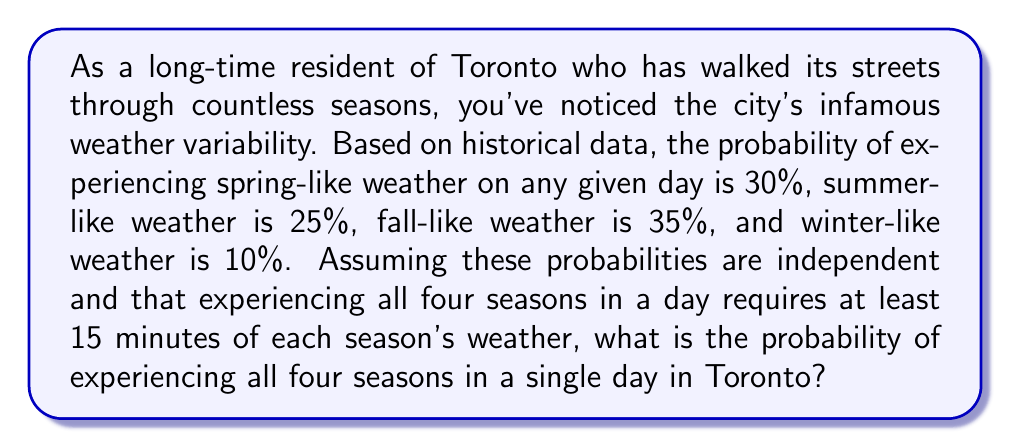Can you answer this question? To solve this problem, we need to use the multiplication rule of probability for independent events. Since we want the probability of all four seasons occurring in a single day, we multiply the individual probabilities of each season occurring.

Let's define our events:
$S$: Spring-like weather occurs for at least 15 minutes
$U$: Summer-like weather occurs for at least 15 minutes
$F$: Fall-like weather occurs for at least 15 minutes
$W$: Winter-like weather occurs for at least 15 minutes

Given probabilities:
$P(S) = 0.30$
$P(U) = 0.25$
$P(F) = 0.35$
$P(W) = 0.10$

The probability of all four seasons occurring in a single day is:

$$P(S \cap U \cap F \cap W) = P(S) \times P(U) \times P(F) \times P(W)$$

Substituting the values:

$$P(S \cap U \cap F \cap W) = 0.30 \times 0.25 \times 0.35 \times 0.10$$

Calculating:

$$P(S \cap U \cap F \cap W) = 0.0026250 = 0.26250\%$$
Answer: The probability of experiencing all four seasons in a single day in Toronto, based on the given historical data, is approximately $0.0026250$ or $0.26250\%$. 